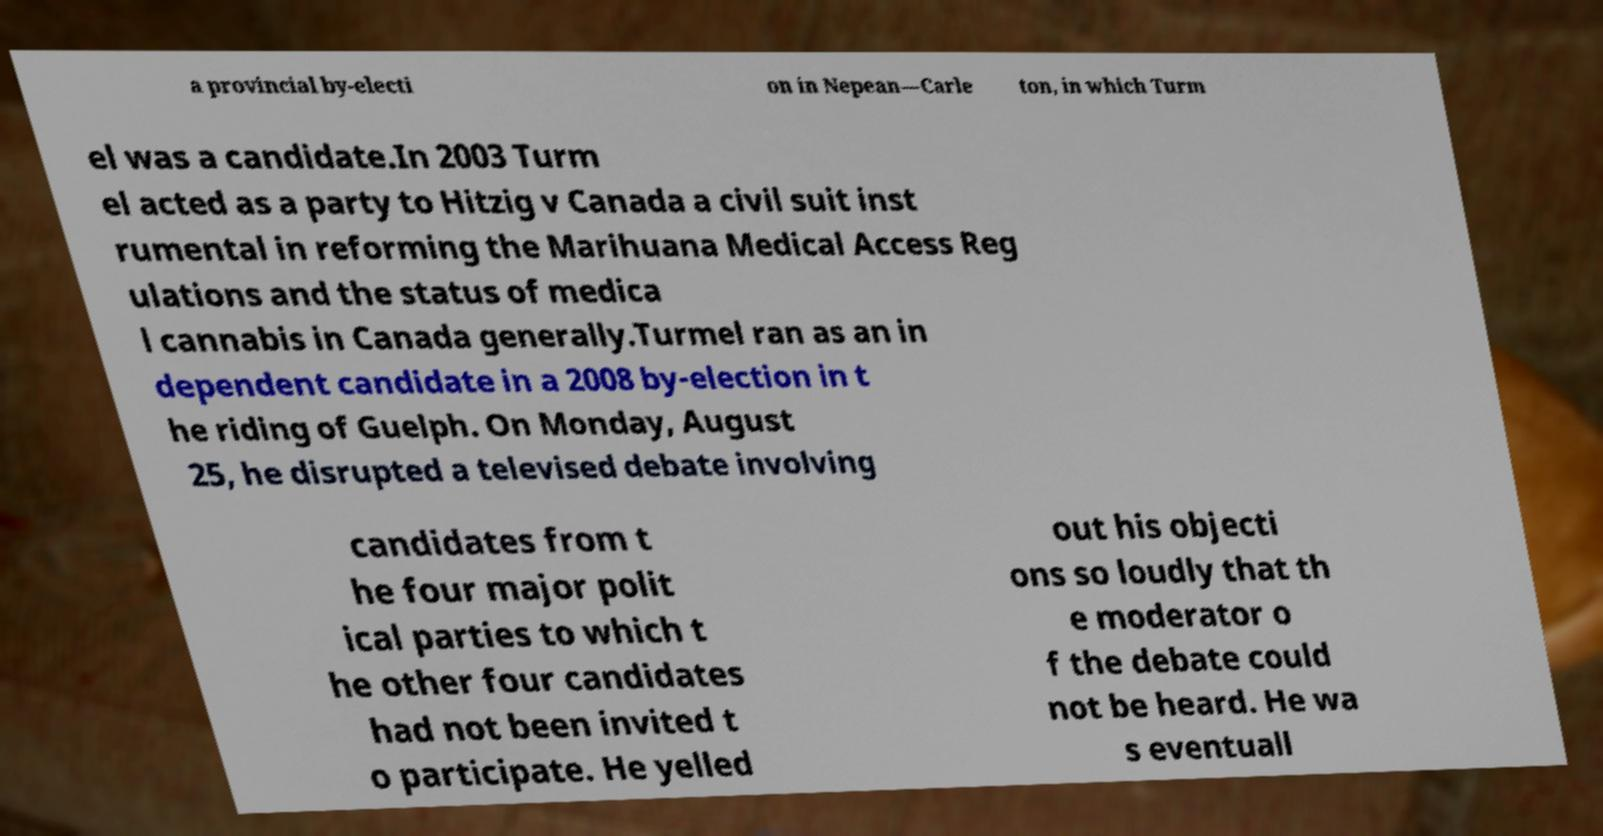I need the written content from this picture converted into text. Can you do that? a provincial by-electi on in Nepean—Carle ton, in which Turm el was a candidate.In 2003 Turm el acted as a party to Hitzig v Canada a civil suit inst rumental in reforming the Marihuana Medical Access Reg ulations and the status of medica l cannabis in Canada generally.Turmel ran as an in dependent candidate in a 2008 by-election in t he riding of Guelph. On Monday, August 25, he disrupted a televised debate involving candidates from t he four major polit ical parties to which t he other four candidates had not been invited t o participate. He yelled out his objecti ons so loudly that th e moderator o f the debate could not be heard. He wa s eventuall 